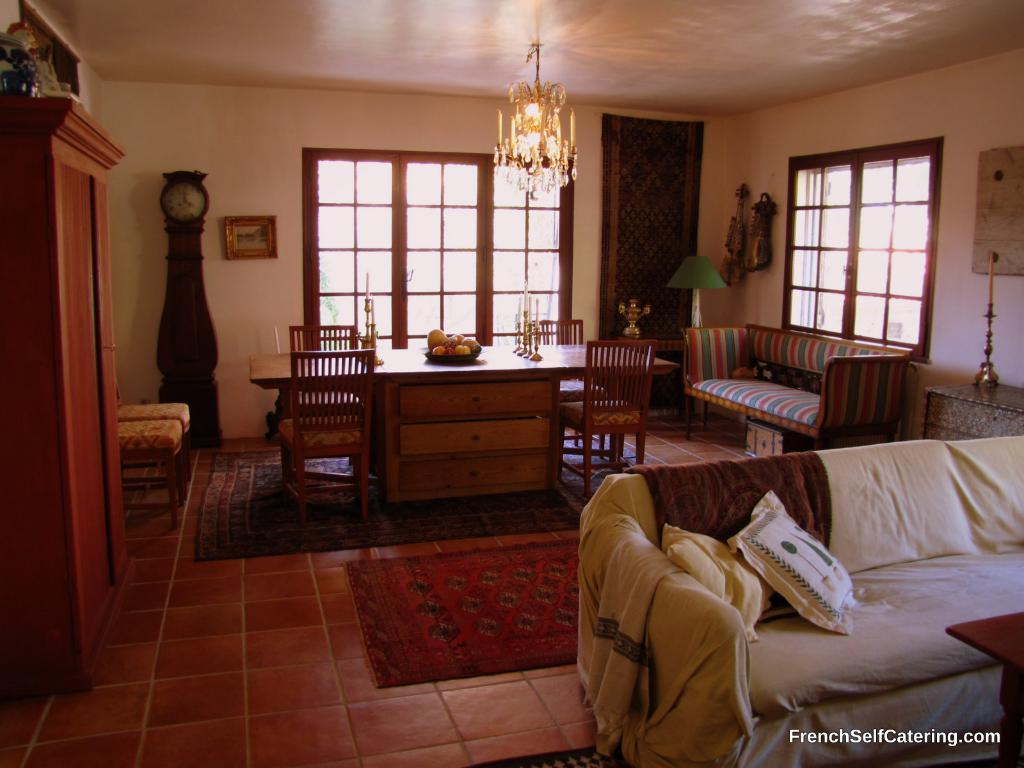What type of furniture is present in the image? There is a table, chairs, sofas, and cushions in the image. What can be seen on the wall in the background of the image? There is a frame on the wall in the background of the image. Is there any indication of time in the image? Yes, there is a clock in the background of the image. What type of pest can be seen crawling on the sofas in the image? There are no pests visible in the image; it only shows furniture and a clock. Can you tell me what type of kettle is used to make tea in the image? There is no kettle present in the image. 